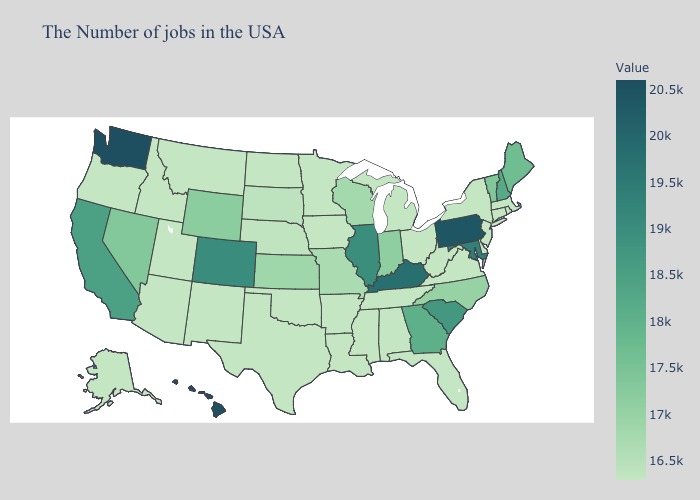Does Maryland have the lowest value in the USA?
Quick response, please. No. Does North Dakota have the lowest value in the USA?
Short answer required. Yes. Does the map have missing data?
Write a very short answer. No. Does Louisiana have the highest value in the USA?
Short answer required. No. Among the states that border New Mexico , which have the highest value?
Answer briefly. Colorado. 